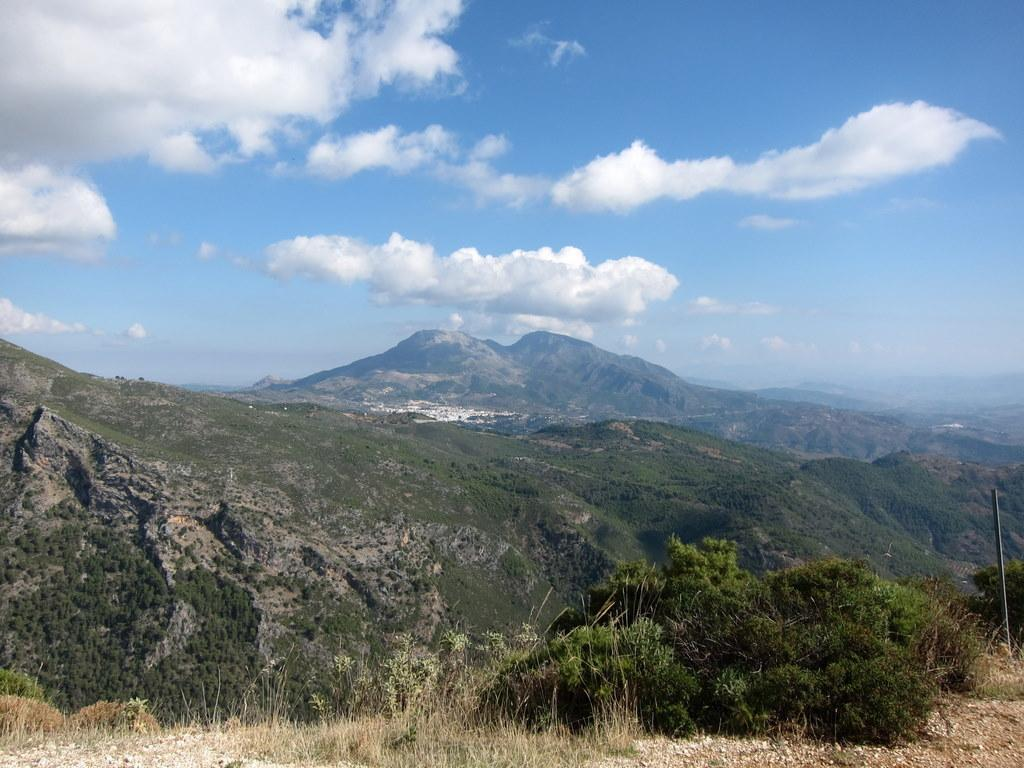What type of vegetation is present at the bottom of the image? There is grass and plants at the bottom of the image. What can be seen on the right side of the image? There is a pole on the right side of the image, on the ground. What is visible in the background of the image? There are hills and clouds in the sky in the background of the image. How many snails can be seen crawling on the grass in the image? There are no snails visible in the image; it only shows grass, plants, a pole, hills, and clouds. What is the level of disgust present in the image? There is no indication of disgust in the image, as it features natural elements such as grass, plants, a pole, hills, and clouds. 